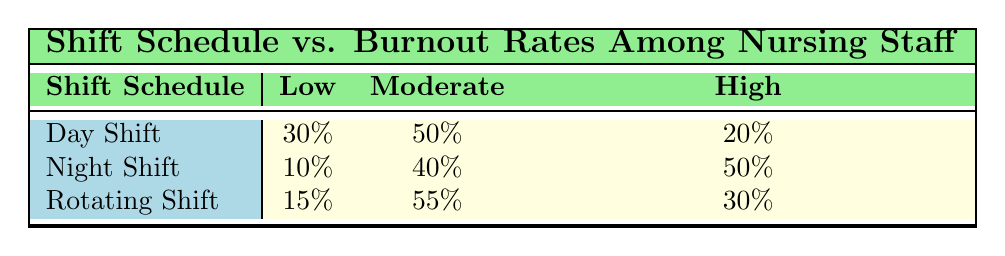What is the burnout rate for nursing staff on day shifts that is classified as high? According to the table, the day shift has a high burnout rate of 20%. This value can be found directly in the corresponding row under the "High" column for "Day Shift".
Answer: 20% What percentage of nursing staff on night shifts experience low burnout rates? The table indicates that 10% of nursing staff on night shifts report low burnout rates, as seen in the "Low" column for "Night Shift".
Answer: 10% Which shift schedule has the highest percentage of moderate burnout rates? Comparing the percentages from the moderate burnout rates across the shift schedules, "Rotating Shift" has the highest percentage at 55%, which is greater than both "Day Shift" (50%) and "Night Shift" (40%).
Answer: Rotating Shift Is it true that more nursing staff on the rotating shift experience high burnout than those on the day shift? Yes, the table shows that 30% of nursing staff on rotating shifts have a high burnout rate, while only 20% of those on day shifts do. Thus, it is true that more on rotating shifts report high burnout rates.
Answer: Yes What is the overall percentage of nursing staff across all shifts that experience a moderate burnout rate? To calculate the overall percentage, we sum the moderate burnout rates from all shifts: Day Shift (50%) + Night Shift (40%) + Rotating Shift (55%) = 145%. To find the average for the three shifts, divide by 3: 145%/3 = 48.33%.
Answer: 48.33% 